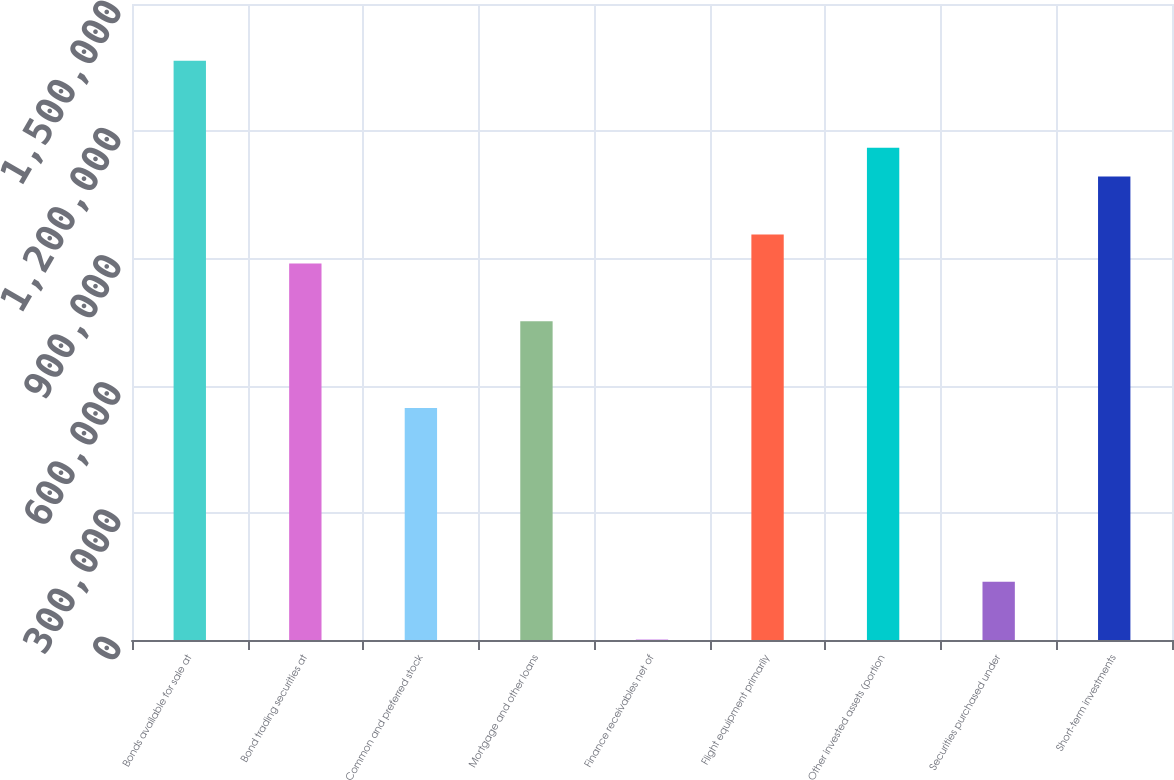Convert chart to OTSL. <chart><loc_0><loc_0><loc_500><loc_500><bar_chart><fcel>Bonds available for sale at<fcel>Bond trading securities at<fcel>Common and preferred stock<fcel>Mortgage and other loans<fcel>Finance receivables net of<fcel>Flight equipment primarily<fcel>Other invested assets (portion<fcel>Securities purchased under<fcel>Short-term investments<nl><fcel>1.36602e+06<fcel>888215<fcel>546928<fcel>751700<fcel>870<fcel>956472<fcel>1.16124e+06<fcel>137385<fcel>1.09299e+06<nl></chart> 